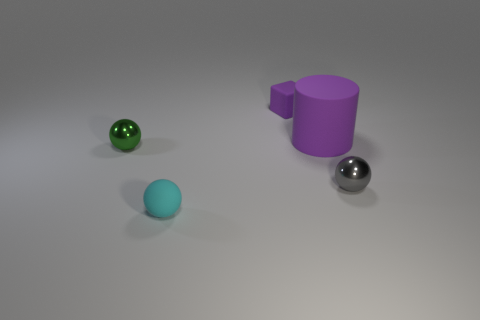Is there anything else that has the same material as the tiny green thing?
Give a very brief answer. Yes. Is there a rubber sphere behind the small thing to the right of the small cube?
Offer a very short reply. No. How many objects are either shiny objects that are right of the green ball or things that are to the left of the rubber cube?
Provide a succinct answer. 3. Are there any other things that are the same color as the large rubber cylinder?
Your answer should be very brief. Yes. What is the color of the metallic thing in front of the metal ball that is left of the small sphere right of the big object?
Your response must be concise. Gray. How big is the ball on the left side of the sphere in front of the gray object?
Make the answer very short. Small. What is the small thing that is in front of the green metal sphere and left of the large purple matte cylinder made of?
Your answer should be compact. Rubber. Is the size of the purple matte cube the same as the metallic thing in front of the green object?
Offer a very short reply. Yes. Are any big cyan cubes visible?
Offer a terse response. No. What is the material of the tiny green thing that is the same shape as the cyan rubber object?
Your answer should be very brief. Metal. 